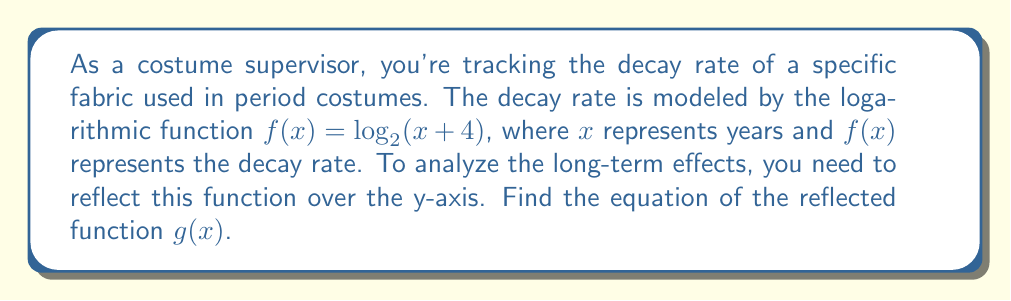Can you solve this math problem? To reflect a function over the y-axis, we replace every $x$ with $-x$ in the original function. This process involves the following steps:

1. Start with the original function: $f(x) = \log_2(x+4)$

2. Replace $x$ with $-x$:
   $g(x) = \log_2((-x)+4)$

3. Simplify the expression inside the parentheses:
   $g(x) = \log_2(-x+4)$

4. The function is now reflected over the y-axis.

To verify, let's consider a few points:
- In $f(x)$, the y-intercept is at (0, 2) because $f(0) = \log_2(0+4) = \log_2(4) = 2$
- In $g(x)$, the y-intercept is also at (0, 2) because $g(0) = \log_2(-0+4) = \log_2(4) = 2$
- For $f(x)$, $f(1) = \log_2(5)$
- For $g(x)$, $g(-1) = \log_2(5)$

This confirms that the graph of $g(x)$ is indeed the reflection of $f(x)$ over the y-axis.
Answer: $g(x) = \log_2(-x+4)$ 